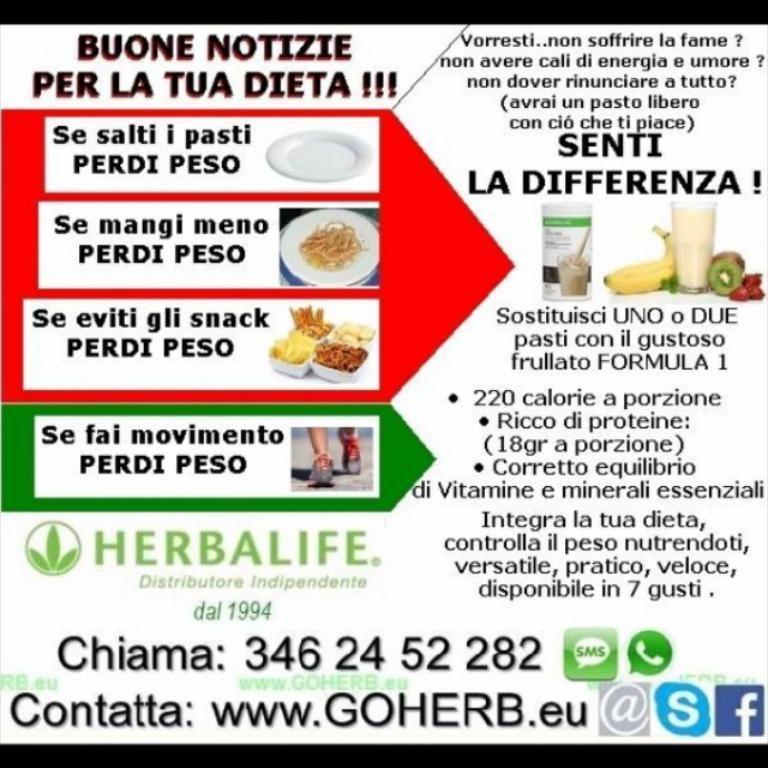What is present on the poster in the image? The poster contains text, numbers, images, and a logo. Can you describe the content of the poster in more detail? The poster contains text, numbers, and images, but it does not specify the content of these elements. The poster also has a logo, which may represent a company or organization. Are there any cornfields or turkeys visible in the image? There is no indication of cornfields or turkeys in the image; it primarily features a poster with text, numbers, images, and a logo. 